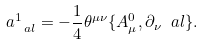Convert formula to latex. <formula><loc_0><loc_0><loc_500><loc_500>\L a ^ { 1 } _ { \ a l } = - \frac { 1 } { 4 } \theta ^ { \mu \nu } \{ A ^ { 0 } _ { \mu } , \partial _ { \nu } \ a l \} .</formula> 